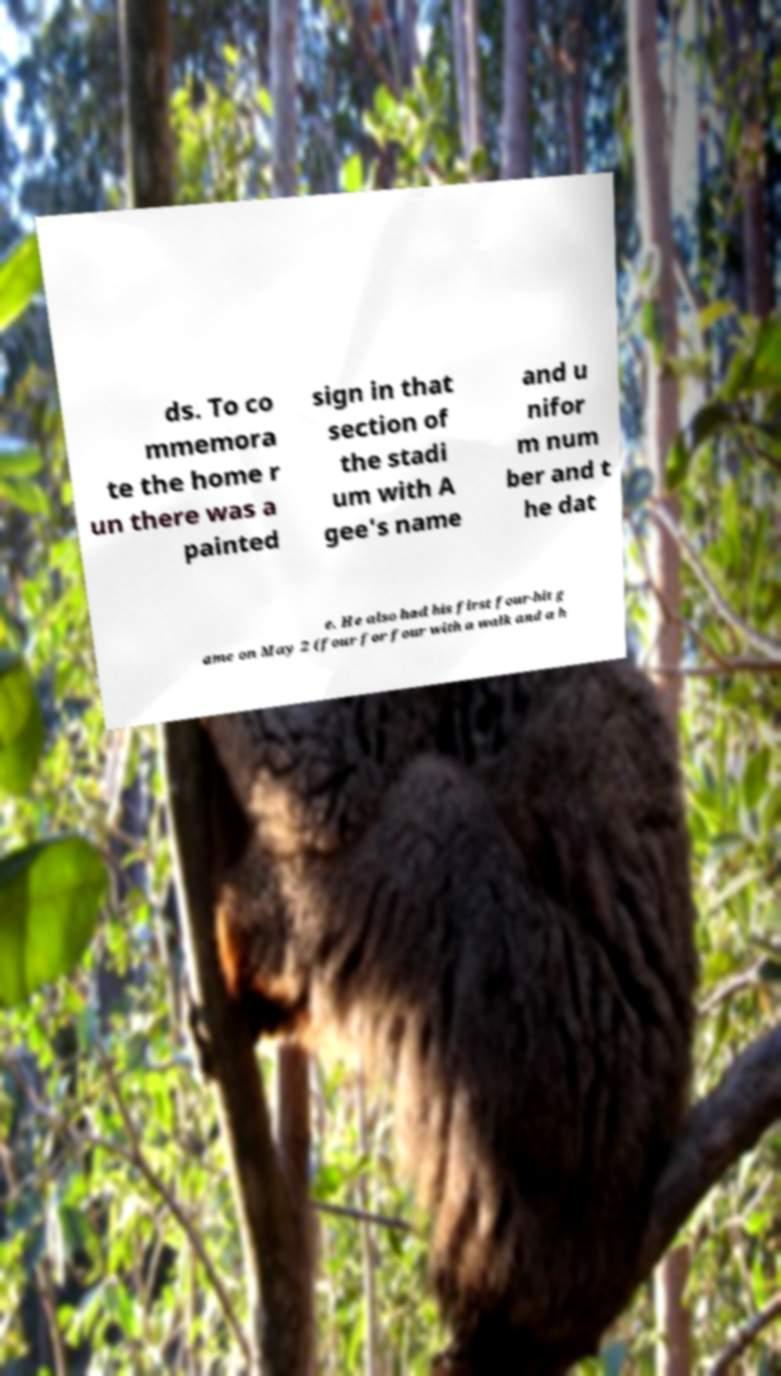Could you extract and type out the text from this image? ds. To co mmemora te the home r un there was a painted sign in that section of the stadi um with A gee's name and u nifor m num ber and t he dat e. He also had his first four-hit g ame on May 2 (four for four with a walk and a h 